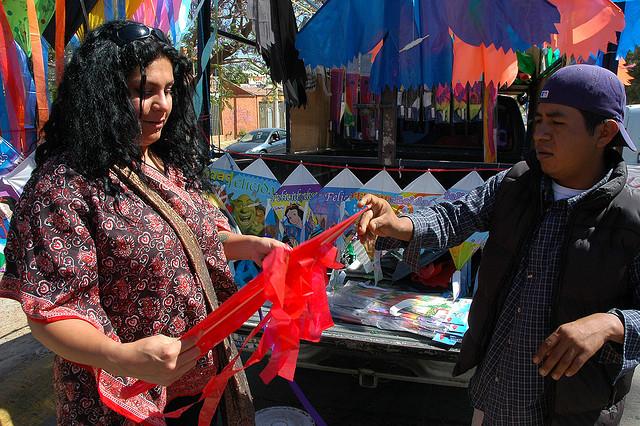How many people are wearing hats?
Quick response, please. 1. Where is Snow White?
Keep it brief. Book. What is this person holding?
Concise answer only. Ribbon. How many color on her shirt?
Keep it brief. 4. 